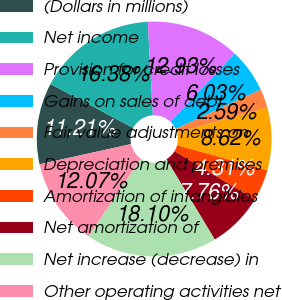Convert chart to OTSL. <chart><loc_0><loc_0><loc_500><loc_500><pie_chart><fcel>(Dollars in millions)<fcel>Net income<fcel>Provision for credit losses<fcel>Gains on sales of debt<fcel>Fair value adjustments on<fcel>Depreciation and premises<fcel>Amortization of intangibles<fcel>Net amortization of<fcel>Net increase (decrease) in<fcel>Other operating activities net<nl><fcel>11.21%<fcel>16.38%<fcel>12.93%<fcel>6.03%<fcel>2.59%<fcel>8.62%<fcel>4.31%<fcel>7.76%<fcel>18.1%<fcel>12.07%<nl></chart> 